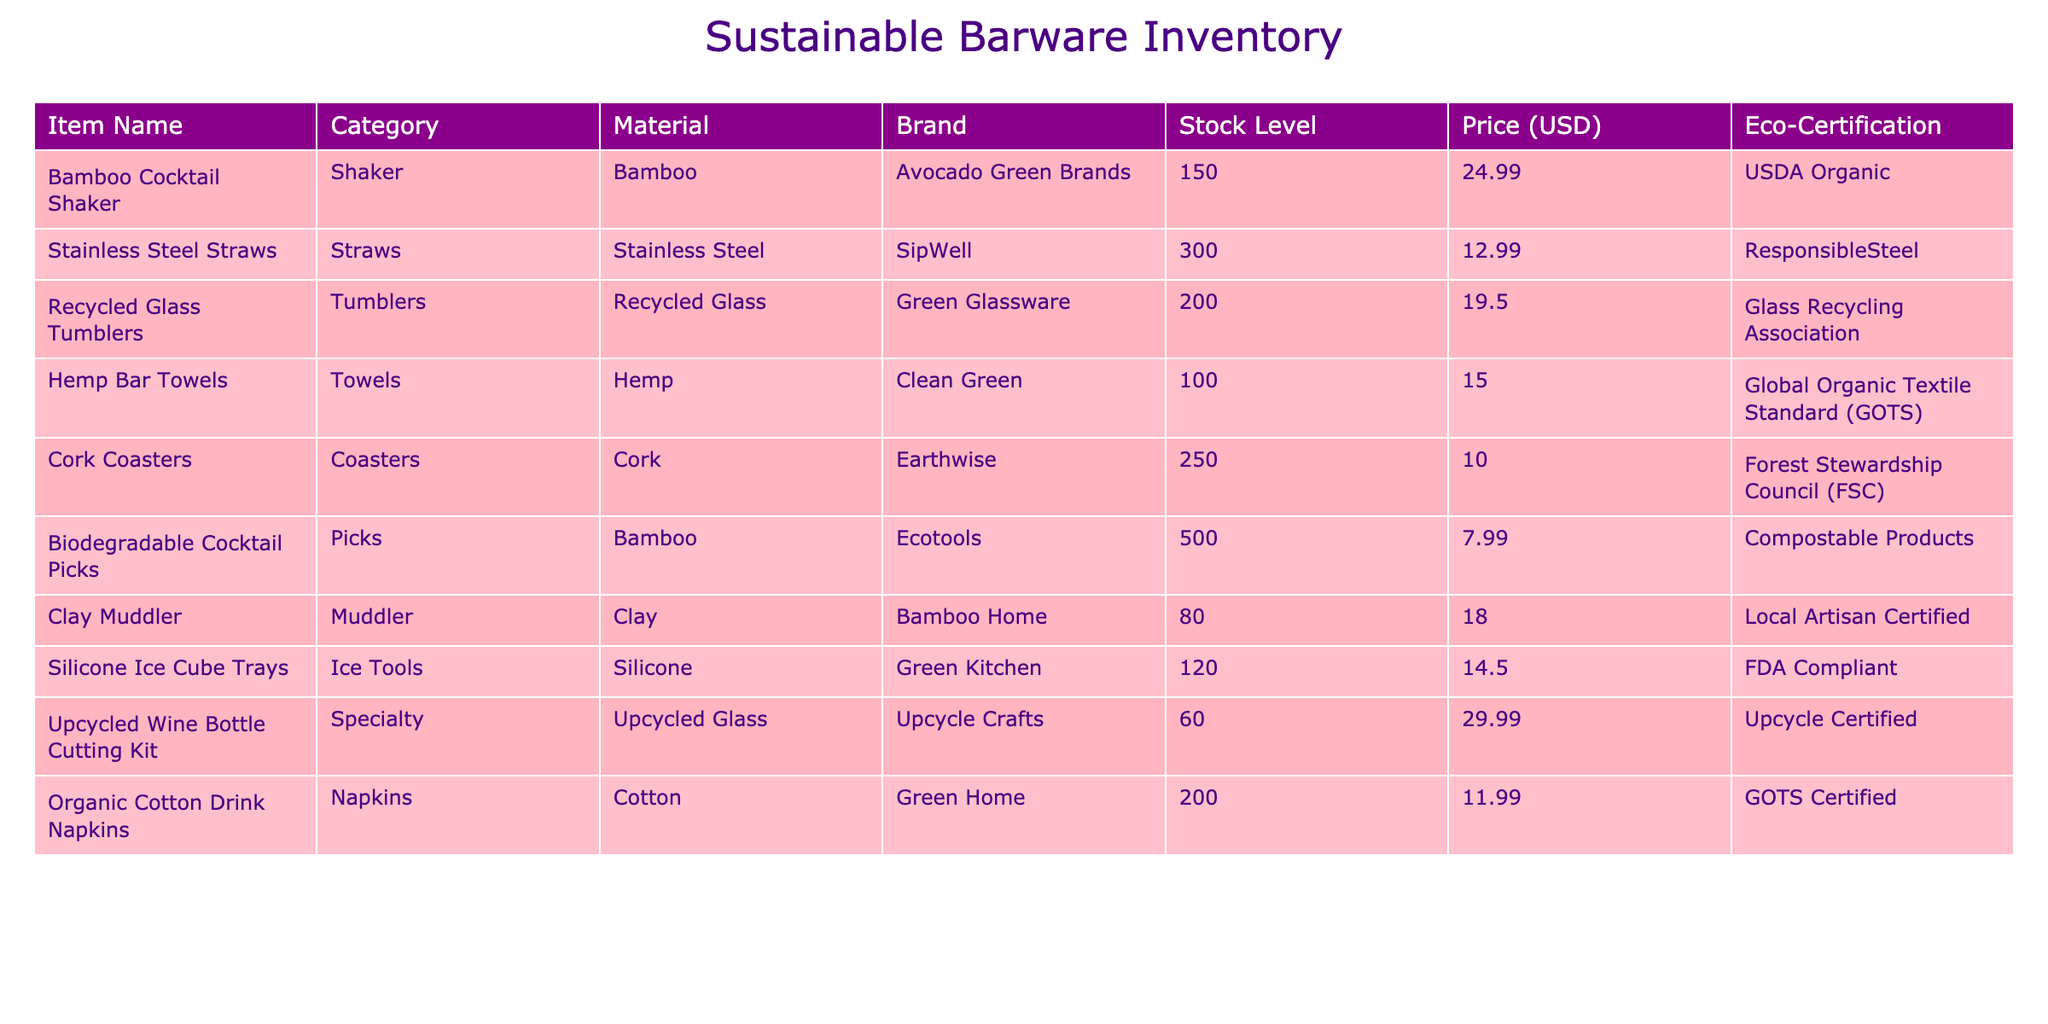What is the stock level of the Bamboo Cocktail Shaker? The stock level for the Bamboo Cocktail Shaker is directly listed in the table as 150 units.
Answer: 150 Which item has the highest stock level? By comparing the stock levels, the item with the highest stock level is the Biodegradable Cocktail Picks, with a stock level of 500 units.
Answer: Biodegradable Cocktail Picks What is the average price of all items in the inventory? To find the average price, sum the prices of all items: (24.99 + 12.99 + 19.50 + 15.00 + 10.00 + 7.99 + 18.00 + 14.50 + 29.99 + 11.99) =  150.95, then divide by the number of items (10): 150.95 / 10 = 15.095. Therefore, the average price is approximately 15.10.
Answer: 15.10 Is the Cork Coasters item made of eco-friendly material? The table specifies that Cork Coasters are made of cork, which is considered an eco-friendly material. Thus, the answer is yes.
Answer: Yes What is the total stock level of all items made from natural or renewable materials? We need to identify the relevant items: Bamboo Cocktail Shaker (150), Cork Coasters (250), Hemp Bar Towels (100), and Biodegradable Cocktail Picks (500). Adding these stock levels gives us a total of (150 + 250 + 100 + 500) = 1000.
Answer: 1000 How many items in the inventory are certified by the Global Organic Textile Standard (GOTS)? The only item certified by GOTS is the Hemp Bar Towels. Thus, there is one item with this certification.
Answer: 1 What percentage of the total stock is contributed by the Stainless Steel Straws? First, find the total stock level: (150 + 300 + 200 + 100 + 250 + 500 + 80 + 120 + 60 + 200) = 2060. Then, the stock level for Stainless Steel Straws is 300. The percentage is (300 / 2060) * 100 = 14.56%.
Answer: 14.56% Is the price of the Upcycled Wine Bottle Cutting Kit higher than the average price of the inventory? The price of the Upcycled Wine Bottle Cutting Kit is 29.99, and the average price calculated earlier is 15.10. Since 29.99 is greater than 15.10, the answer is yes.
Answer: Yes Which brand has the most diverse categories of products in the inventory? Looking at the brands listed, Ecotools produces the Biodegradable Cocktail Picks (Picks), and Bamboo Home produces the Clay Muddler (Muddler). The diversity is limited, so the brands do not cover multiple categories. However, Avocado Green Brands produces only one, while Clean Green has only towels. Hence, no brand stands out in product categories.
Answer: No brand has diverse categories 